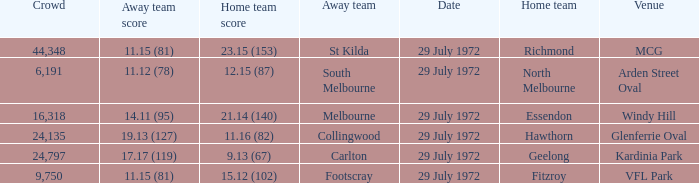When collingwood was the away team, what was the home team? Hawthorn. 